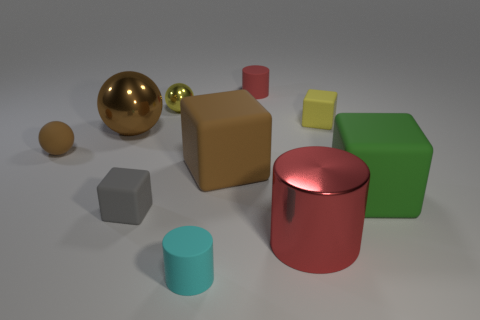Subtract all cyan cylinders. How many cylinders are left? 2 Subtract all brown spheres. How many red cylinders are left? 2 Subtract all gray cubes. How many cubes are left? 3 Subtract 1 cubes. How many cubes are left? 3 Subtract all cyan blocks. Subtract all green spheres. How many blocks are left? 4 Subtract all cylinders. How many objects are left? 7 Subtract all red matte things. Subtract all cubes. How many objects are left? 5 Add 9 big brown cubes. How many big brown cubes are left? 10 Add 9 small green metal cylinders. How many small green metal cylinders exist? 9 Subtract 1 yellow spheres. How many objects are left? 9 